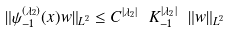<formula> <loc_0><loc_0><loc_500><loc_500>\| \psi _ { - 1 } ^ { ( \lambda _ { 2 } ) } ( x ) w \| _ { L ^ { 2 } } \leq C ^ { | \lambda _ { 2 } | } \ K _ { - 1 } ^ { | \lambda _ { 2 } | } \ \| w \| _ { L ^ { 2 } }</formula> 